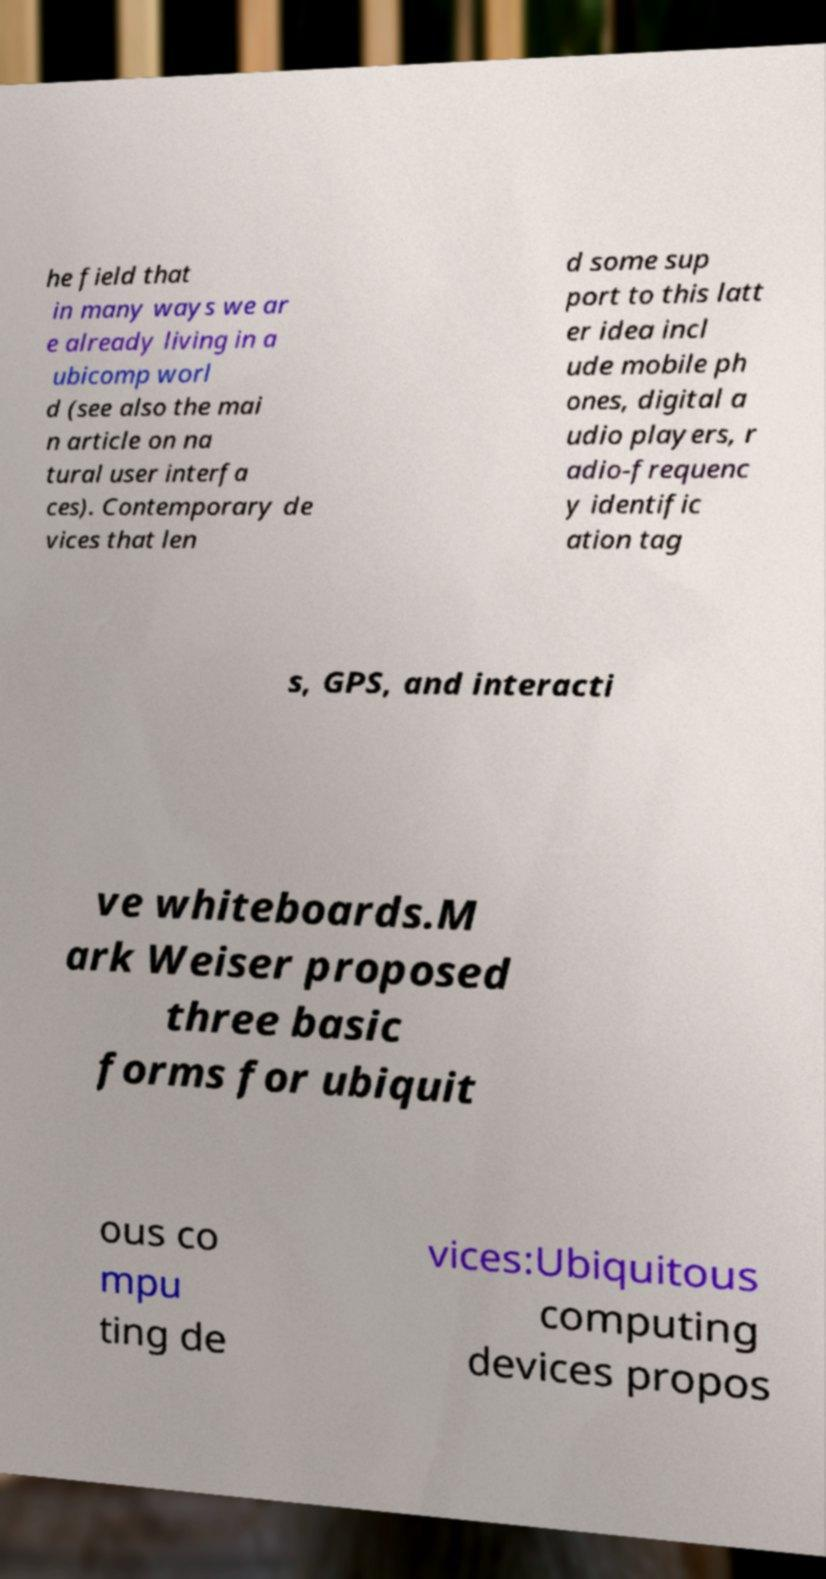Please read and relay the text visible in this image. What does it say? he field that in many ways we ar e already living in a ubicomp worl d (see also the mai n article on na tural user interfa ces). Contemporary de vices that len d some sup port to this latt er idea incl ude mobile ph ones, digital a udio players, r adio-frequenc y identific ation tag s, GPS, and interacti ve whiteboards.M ark Weiser proposed three basic forms for ubiquit ous co mpu ting de vices:Ubiquitous computing devices propos 